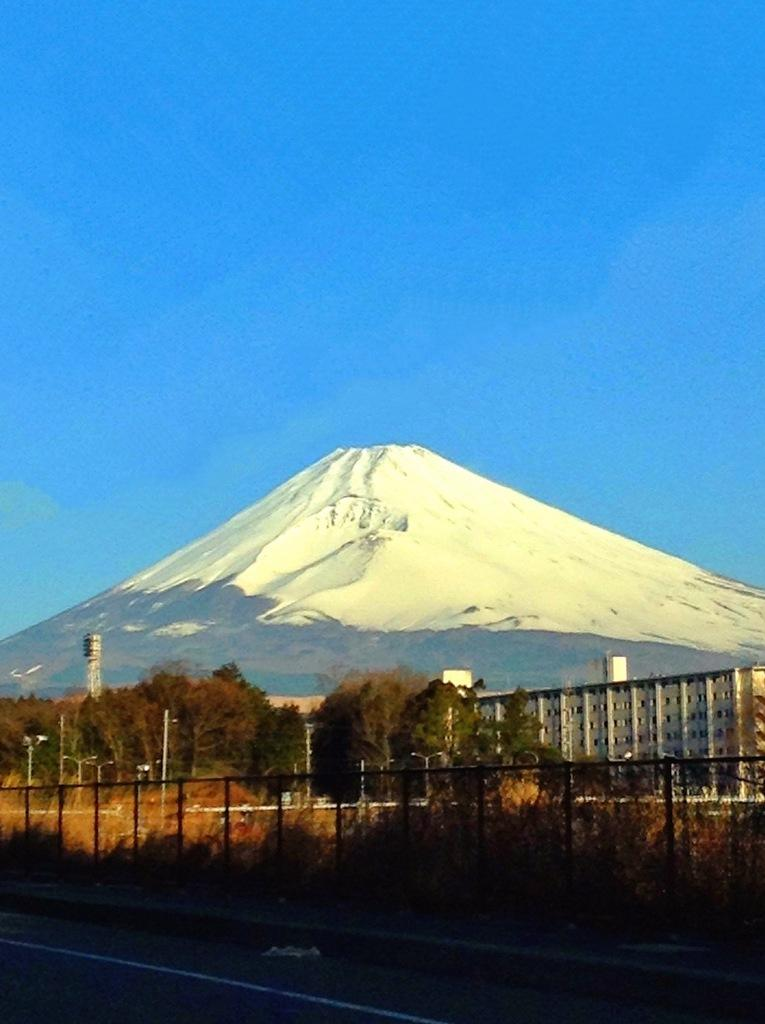What is the main feature of the image? There is a road in the image. What is located near the road? There is a sidewalk with fencing near the road. What can be seen in the background of the image? There are trees, a building, a hill, and the sky visible in the background of the image. How many bones are visible in the image? There are no bones visible in the image. What type of hands are holding the fence in the image? There are no hands visible in the image. 